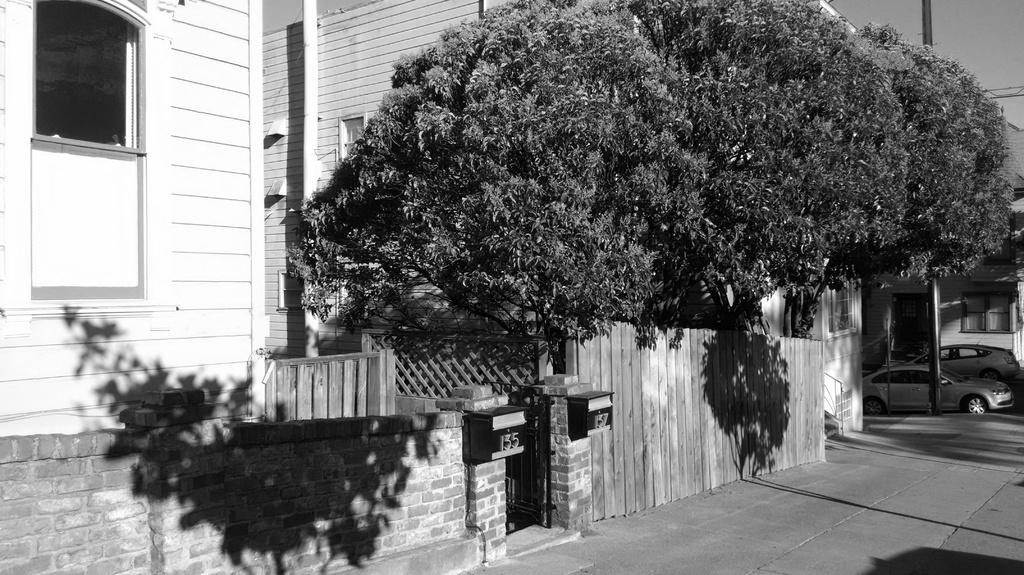What type of structures can be seen in the image? There are buildings in the image. What type of vegetation is present in the image? There are trees in the image. What type of vehicles can be seen in the image? There are cars in the image. What object can be seen standing upright in the image? There is a pole in the image. What type of writing can be seen on the trees in the image? There is no writing present on the trees in the image. What type of root is visible growing from the pole in the image? There is no root visible growing from the pole in the image. What type of knife can be seen cutting the cars in the image? There is no knife present in the image, and the cars are not being cut. 